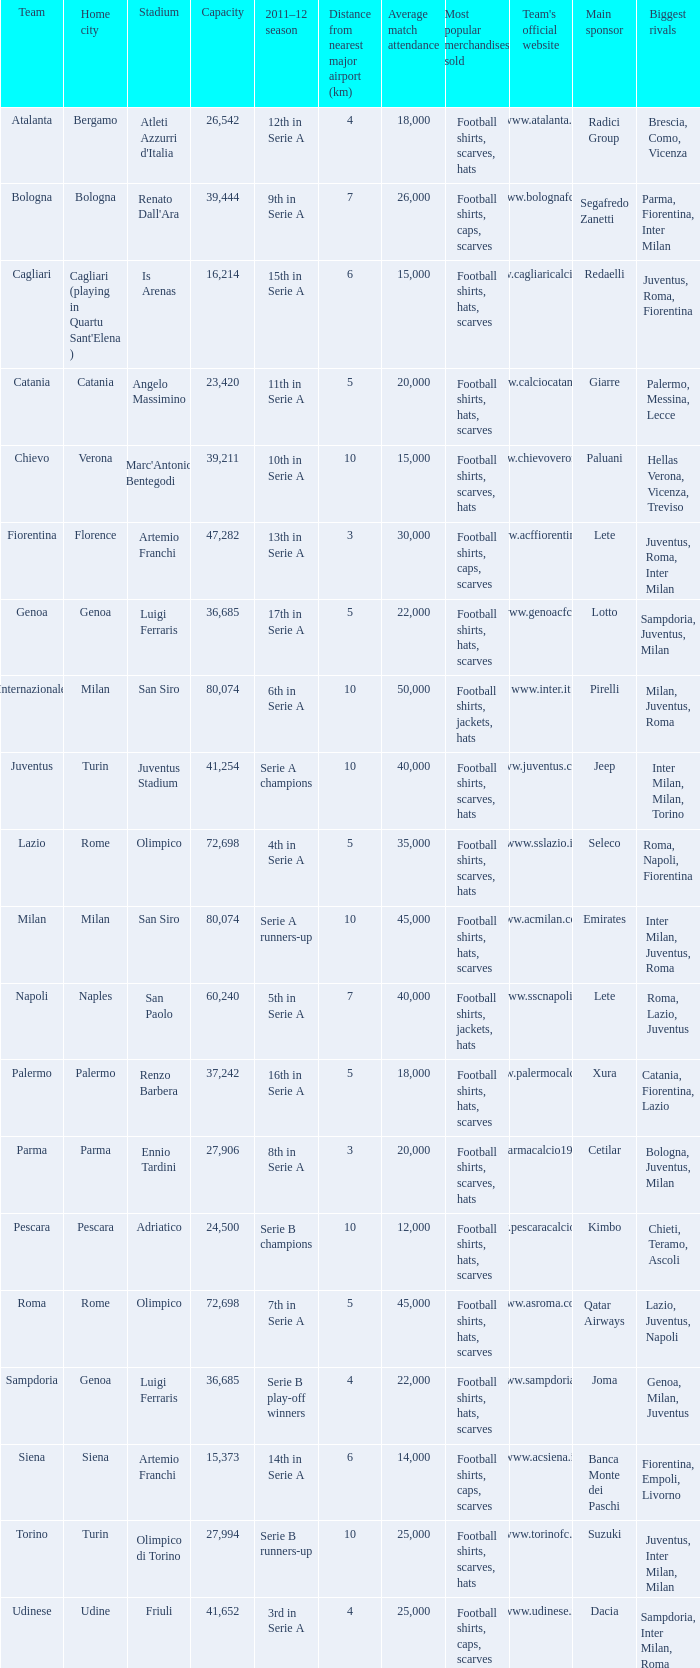What is the home city for angelo massimino stadium? Catania. 